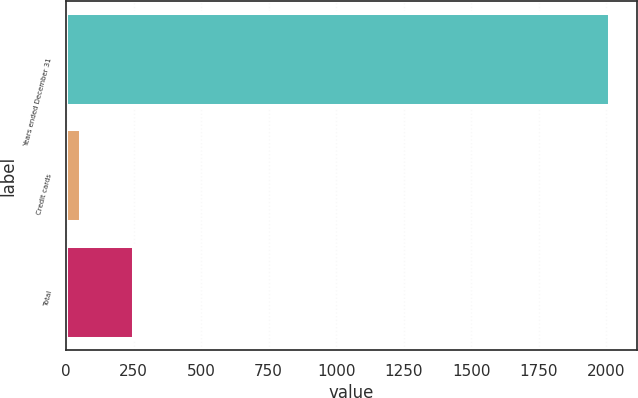Convert chart. <chart><loc_0><loc_0><loc_500><loc_500><bar_chart><fcel>Years ended December 31<fcel>Credit cards<fcel>Total<nl><fcel>2013<fcel>56<fcel>251.7<nl></chart> 